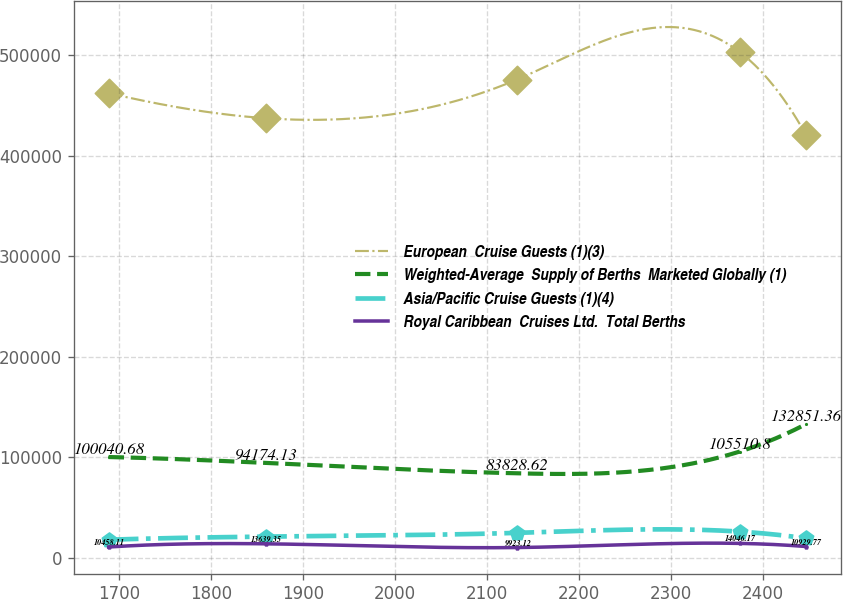Convert chart. <chart><loc_0><loc_0><loc_500><loc_500><line_chart><ecel><fcel>European  Cruise Guests (1)(3)<fcel>Weighted-Average  Supply of Berths  Marketed Globally (1)<fcel>Asia/Pacific Cruise Guests (1)(4)<fcel>Royal Caribbean  Cruises Ltd.  Total Berths<nl><fcel>1688.73<fcel>462317<fcel>100041<fcel>17716.5<fcel>10458.1<nl><fcel>1859.73<fcel>437335<fcel>94174.1<fcel>20793<fcel>13639.4<nl><fcel>2132.61<fcel>475753<fcel>83828.6<fcel>24519.8<fcel>9923.12<nl><fcel>2375.19<fcel>503125<fcel>105511<fcel>25773.5<fcel>14046.2<nl><fcel>2447.17<fcel>420738<fcel>132851<fcel>19031.9<fcel>10929.8<nl></chart> 